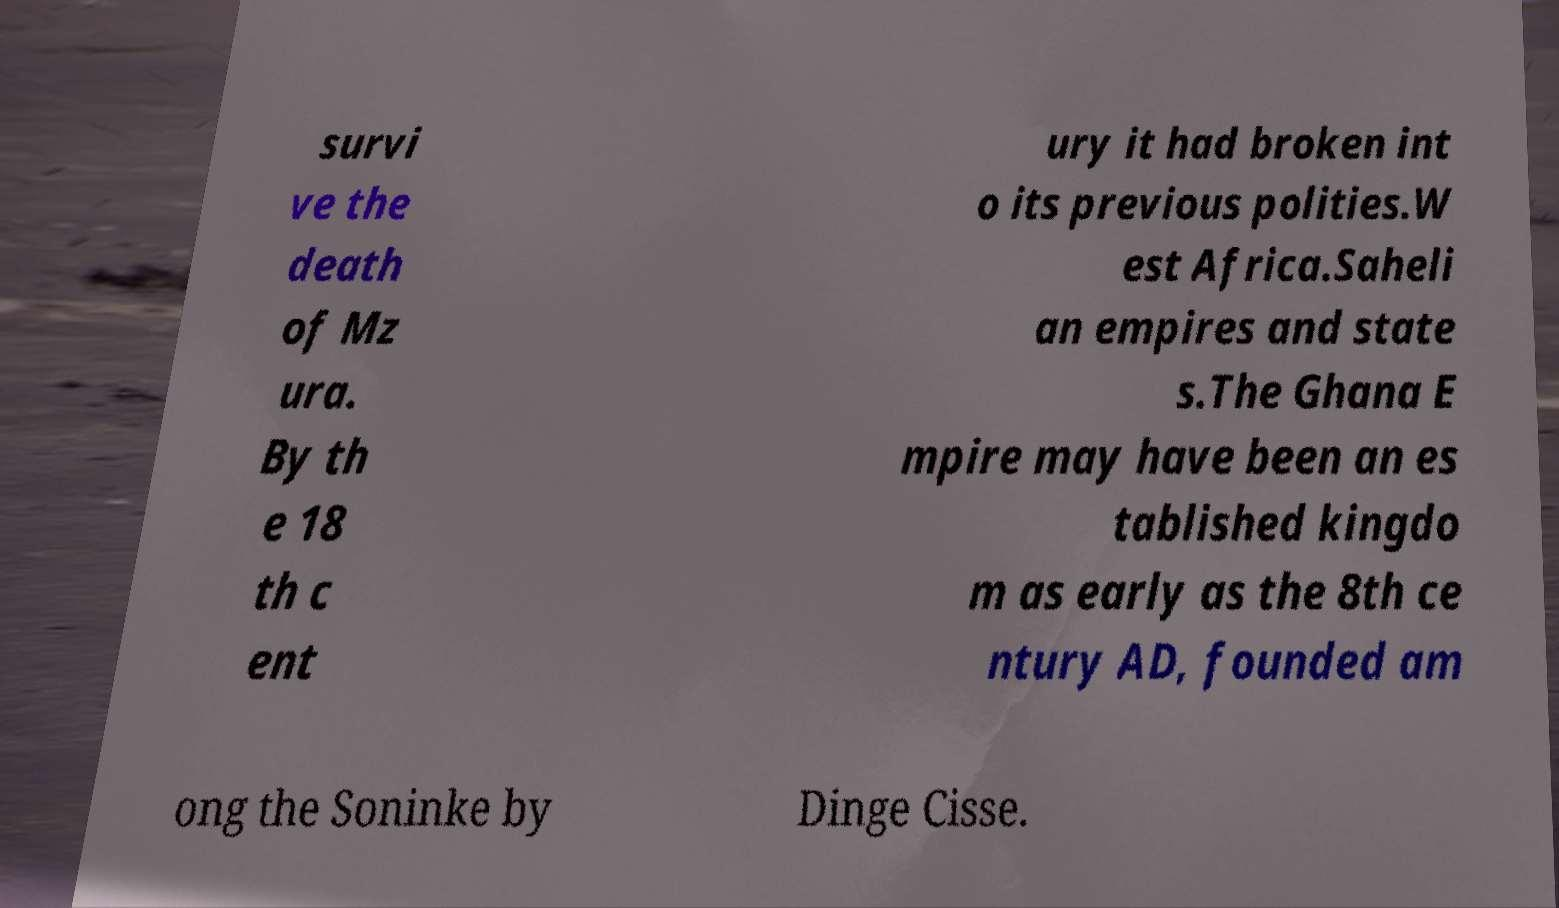What messages or text are displayed in this image? I need them in a readable, typed format. survi ve the death of Mz ura. By th e 18 th c ent ury it had broken int o its previous polities.W est Africa.Saheli an empires and state s.The Ghana E mpire may have been an es tablished kingdo m as early as the 8th ce ntury AD, founded am ong the Soninke by Dinge Cisse. 